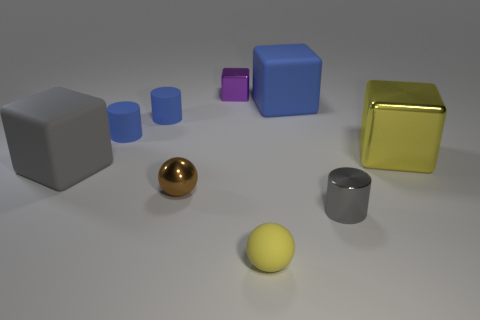What is the shape of the purple thing?
Your answer should be very brief. Cube. Does the gray object behind the tiny brown sphere have the same material as the large blue cube?
Provide a succinct answer. Yes. How big is the yellow thing to the left of the yellow thing that is right of the small metal cylinder?
Provide a succinct answer. Small. What color is the shiny thing that is both behind the small brown metal ball and to the left of the yellow rubber ball?
Give a very brief answer. Purple. What material is the purple block that is the same size as the brown shiny thing?
Offer a very short reply. Metal. What number of other things are the same material as the tiny purple block?
Make the answer very short. 3. Do the small ball behind the matte ball and the large matte thing right of the small brown metal object have the same color?
Your response must be concise. No. There is a big matte thing right of the block left of the shiny ball; what is its shape?
Provide a short and direct response. Cube. What number of other objects are there of the same color as the tiny metal sphere?
Make the answer very short. 0. Is the material of the big block that is right of the big blue matte block the same as the small ball that is in front of the gray metal cylinder?
Provide a succinct answer. No. 